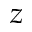Convert formula to latex. <formula><loc_0><loc_0><loc_500><loc_500>z</formula> 